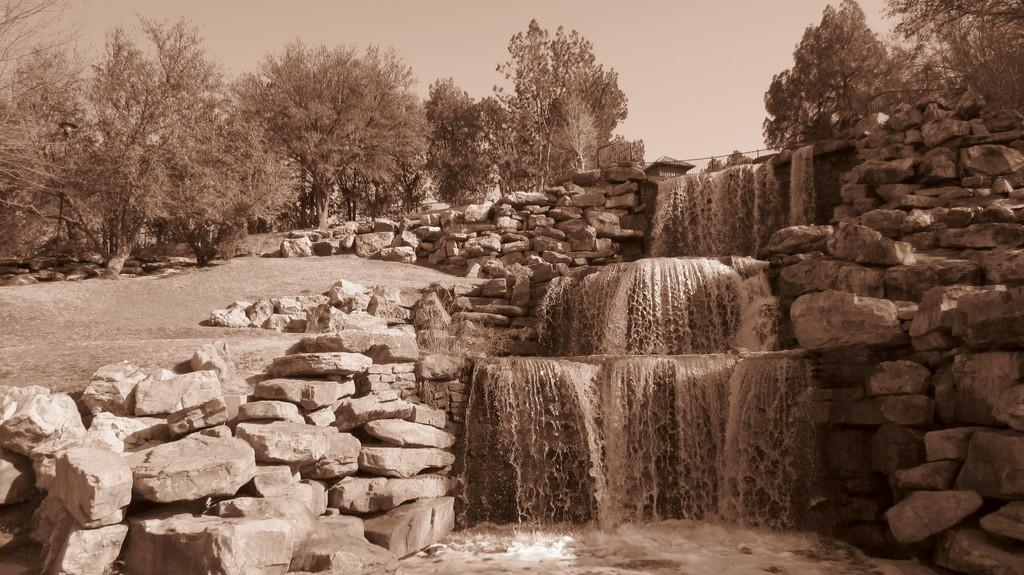What natural feature is the main subject of the image? There is a waterfall in the image. What can be seen on the right side of the image? There are stones on the right side of the image. What structures are visible in the background of the image? There is a hut and a building in the background of the image, along with fencing and trees. What is visible at the top of the image? The sky is visible at the top of the image. What is the tax rate for the waste management services in the image? There is no information about tax rates or waste management services in the image; it features a waterfall and other natural and man-made elements. 